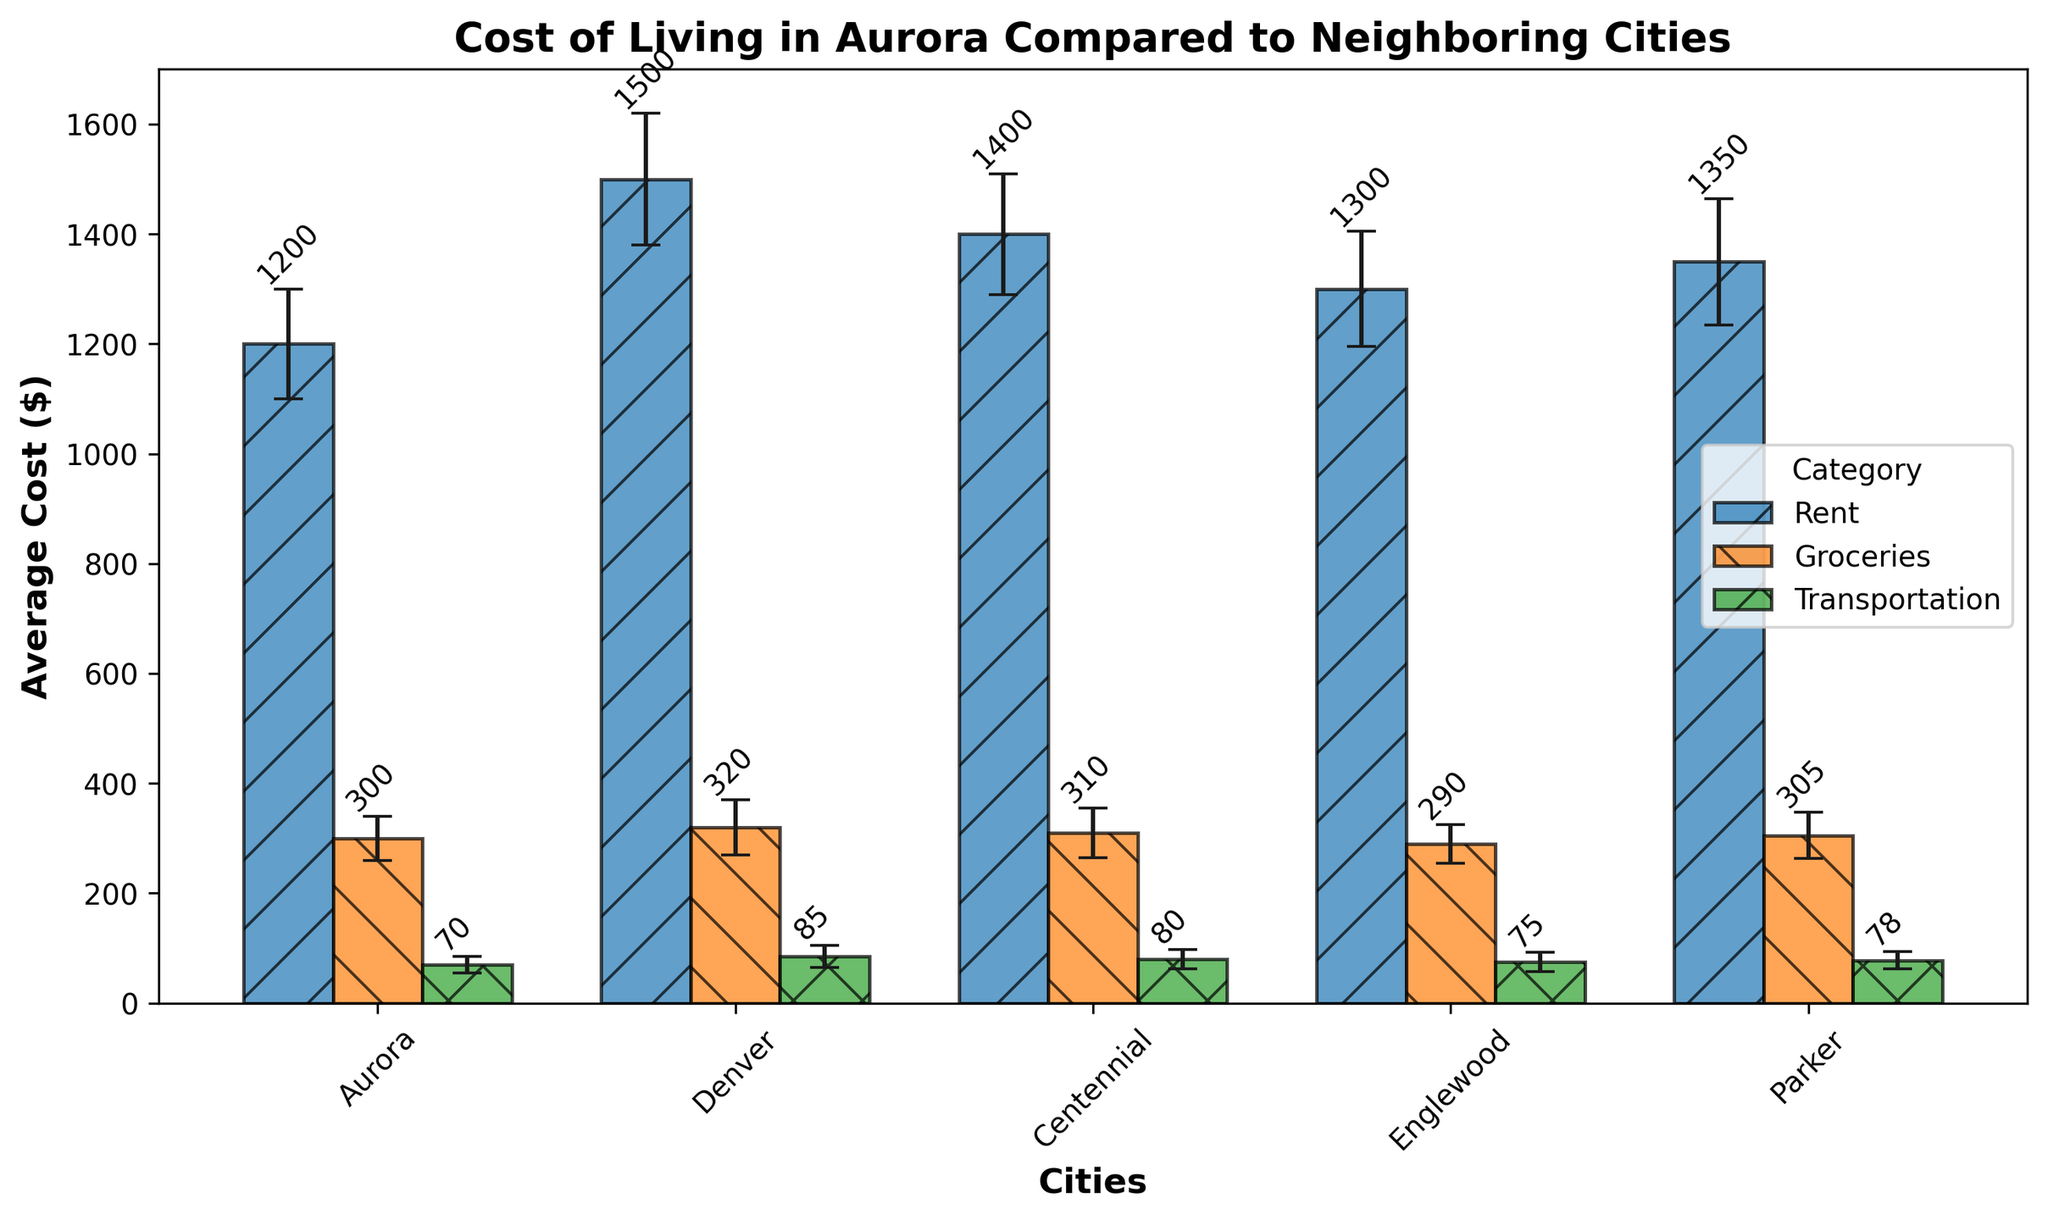What's the difference in average transportation costs between Aurora and Denver? To find the difference, subtract the average transportation cost in Aurora ($70) from the average transportation cost in Denver ($85).
Answer: $15 Which city has the highest average rent cost and what is that cost? The highest average rent cost is in Denver, with an average rent of $1500.
Answer: Denver, $1500 Between Aurora and Englewood, which city has a lower average cost for groceries and by how much? The average cost for groceries in Aurora is $300 and in Englewood, it is $290. To find the difference, subtract $290 from $300.
Answer: Englewood, $10 What's the average of the standard deviations for grocery costs across all cities? The standard deviations for groceries are 40 (Aurora), 50 (Denver), 45 (Centennial), 35 (Englewood), and 42 (Parker). Add them up (40 + 50 + 45 + 35 + 42 = 212) and divide by the number of cities (5).
Answer: 42.4 In which category does Parker have a cost that is lower than the cost in Aurora, and what is the difference for that category? Compare the average costs in Parker and Aurora across all categories: Rent ($1350 vs. $1200), Groceries ($305 vs. $300), and Transportation ($78 vs. $70). None of Parker's costs are lower than Aurora's.
Answer: None What are the total average costs for rent, groceries, and transportation combined in Aurora? Add the average costs in Aurora: Rent ($1200), Groceries ($300), Transportation ($70). The sum is $1200 + $300 + $70 = $1570.
Answer: $1570 Which city shows the largest standard deviation in rent costs, and what is that value? The standard deviations for rent are 100 (Aurora), 120 (Denver), 110 (Centennial), 105 (Englewood), and 115 (Parker). The largest is in Denver with a value of 120.
Answer: Denver, 120 Is the average transportation cost in Englewood higher or lower than in Centennial, and by what amount? The average transportation cost in Englewood is $75, while in Centennial it is $80. The difference is $80 - $75 = $5.
Answer: Lower, $5 